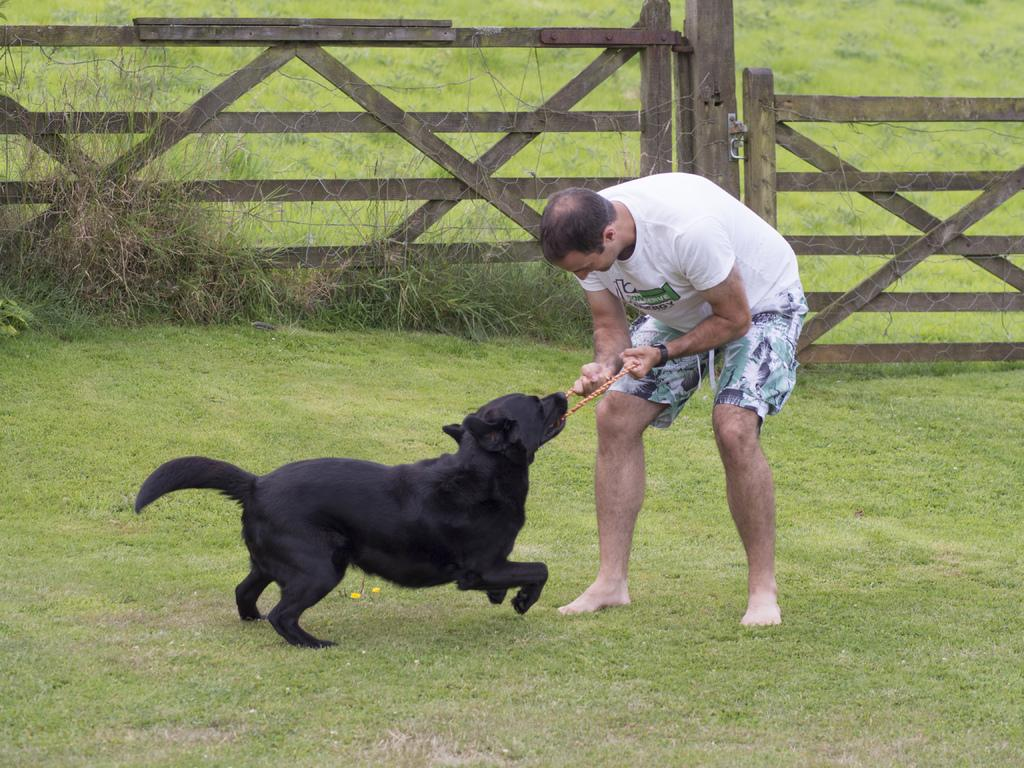What can be seen in the image? There is a person in the image. What is the person wearing? The person is wearing a white shirt. What is the person holding? The person is holding a thread. What is happening with the thread? A black dog is biting the thread. What is located near the person? There is a wooden gate beside the person. What can be observed about the ground in the image? The ground is covered in greenery. Where is the shop located in the image? There is no shop present in the image. What type of brush is being used by the person in the image? There is no brush visible in the image; the person is holding a thread. 